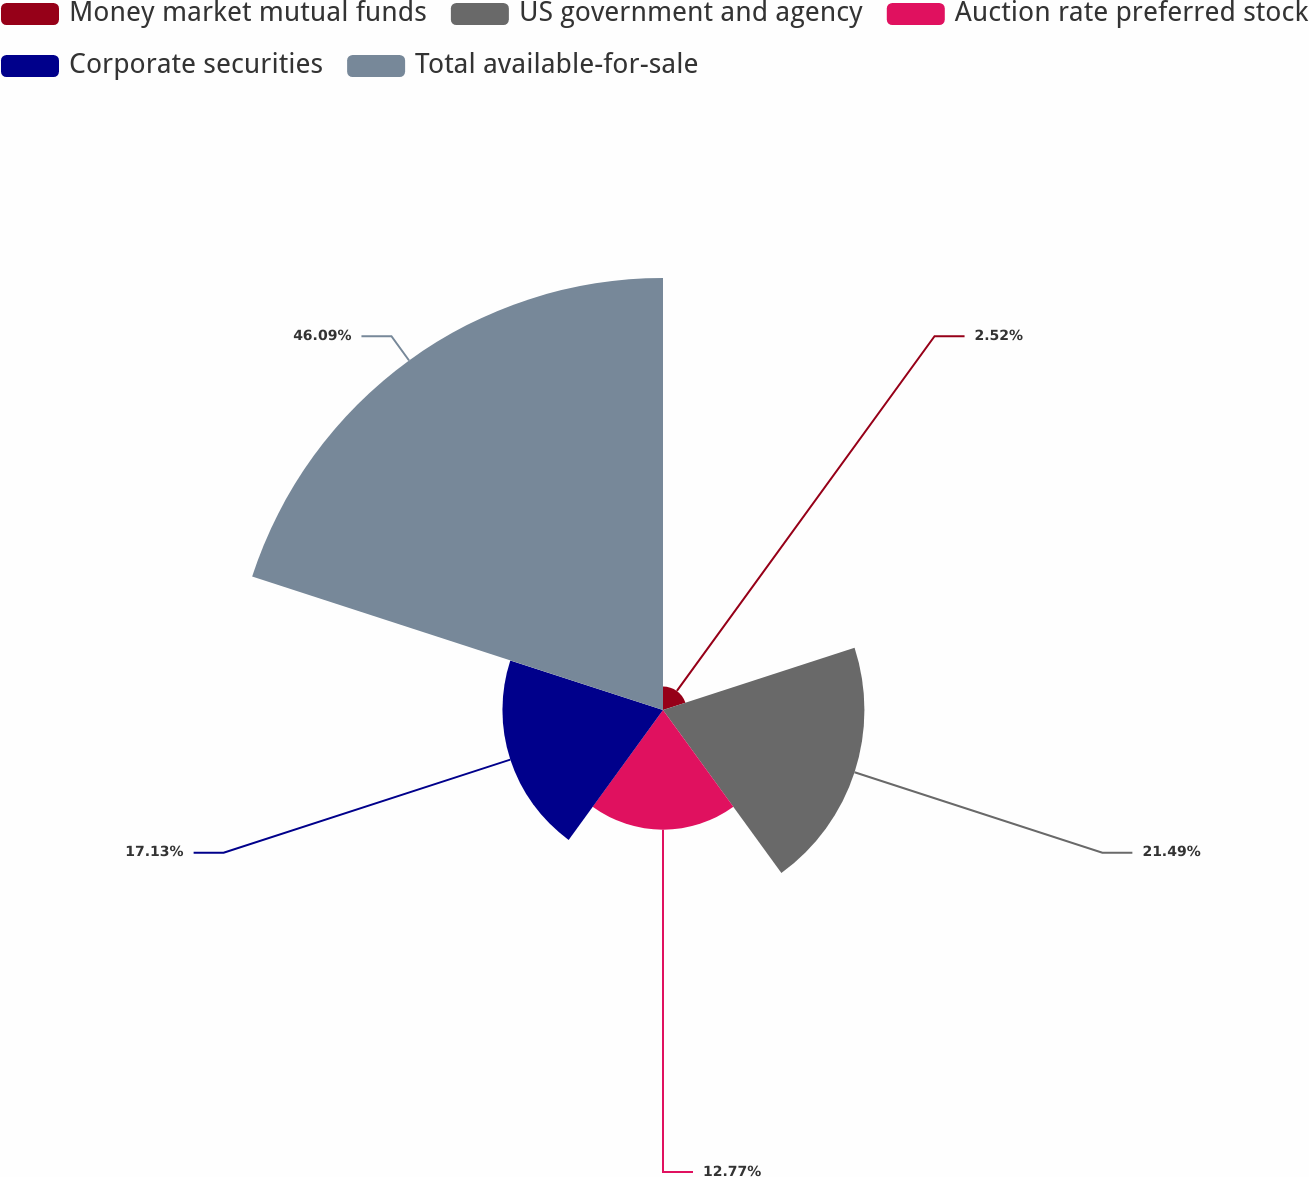Convert chart to OTSL. <chart><loc_0><loc_0><loc_500><loc_500><pie_chart><fcel>Money market mutual funds<fcel>US government and agency<fcel>Auction rate preferred stock<fcel>Corporate securities<fcel>Total available-for-sale<nl><fcel>2.52%<fcel>21.49%<fcel>12.77%<fcel>17.13%<fcel>46.09%<nl></chart> 